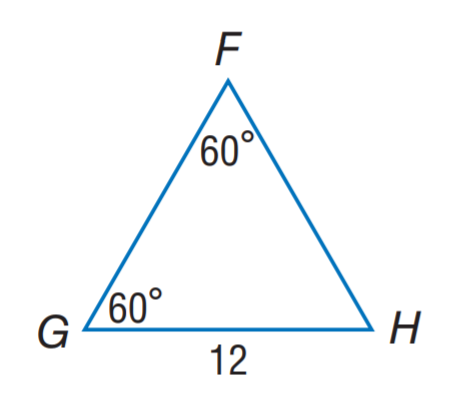Answer the mathemtical geometry problem and directly provide the correct option letter.
Question: Find F H.
Choices: A: 8 B: 10 C: 12 D: 60 C 